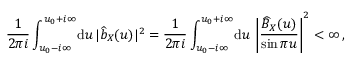<formula> <loc_0><loc_0><loc_500><loc_500>\frac { 1 } { 2 \pi i } \int _ { u _ { 0 } - i \infty } ^ { u _ { 0 } + i \infty } \, d u \, | \widehat { b } _ { X } ( u ) | ^ { 2 } = \frac { 1 } { 2 \pi i } \int _ { u _ { 0 } - i \infty } ^ { u _ { 0 } + i \infty } \, d u \, \left | \frac { \widehat { B } _ { X } ( u ) } { \sin \pi u } \right | ^ { 2 } < \infty \, ,</formula> 